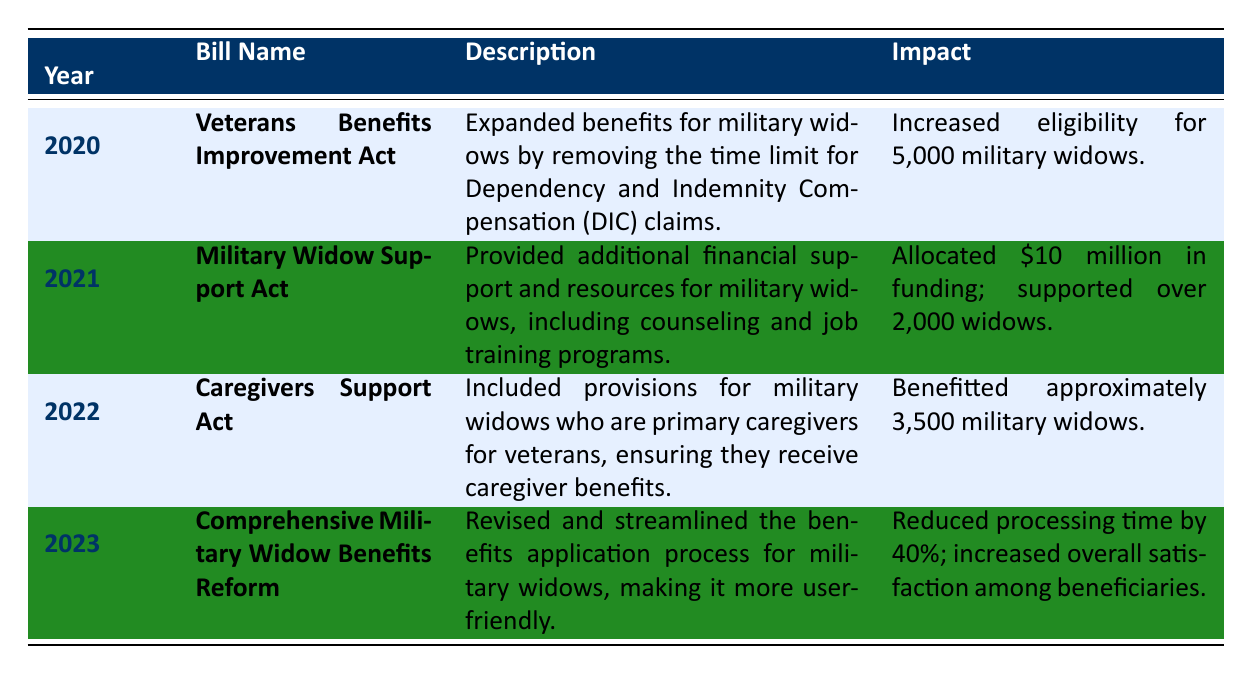What year did the "Veterans Benefits Improvement Act" pass? The table lists the bill names along with their corresponding years. The "Veterans Benefits Improvement Act" is associated with the year 2020.
Answer: 2020 How much funding was allocated by the "Military Widow Support Act"? The "Military Widow Support Act" was noted to have allocated $10 million in funding, as mentioned in the impact section of the table.
Answer: $10 million How many military widows benefited from the "Caregivers Support Act"? According to the table, the "Caregivers Support Act" benefitted approximately 3,500 military widows.
Answer: Approximately 3,500 Which bill provided counseling and job training programs for military widows? The "Military Widow Support Act" is the one that provided additional financial support and resources, including counseling and job training programs for military widows.
Answer: Military Widow Support Act What was the main purpose of the "Comprehensive Military Widow Benefits Reform"? The "Comprehensive Military Widow Benefits Reform" aimed to revise and streamline the benefits application process for military widows, making it user-friendly.
Answer: Streamline the benefits application process How many military widows were newly eligible for benefits due to the "Veterans Benefits Improvement Act"? The "Veterans Benefits Improvement Act" increased eligibility for 5,000 military widows, as referenced in the impact section.
Answer: 5,000 What is the total number of military widows supported by the bills from 2020 to 2022? To find the total, sum the military widows supported by each act: 5,000 (2020) + 2,000 (2021) + 3,500 (2022) = 10,500.
Answer: 10,500 Did any of the legislative changes improve the benefits application processing time? Yes, the "Comprehensive Military Widow Benefits Reform" is stated to have reduced the processing time by 40%, indicating that this change improved the application process.
Answer: Yes Which bill had the greatest impact in terms of the number of military widows affected? The "Veterans Benefits Improvement Act" had the greatest impact with an increase in eligibility for 5,000 military widows, compared to other bills listed.
Answer: Veterans Benefits Improvement Act What was the impact on overall satisfaction among beneficiaries due to the 2023 reform? The table indicates that the "Comprehensive Military Widow Benefits Reform" increased overall satisfaction among beneficiaries, demonstrating a positive impact in this area.
Answer: Increased overall satisfaction 